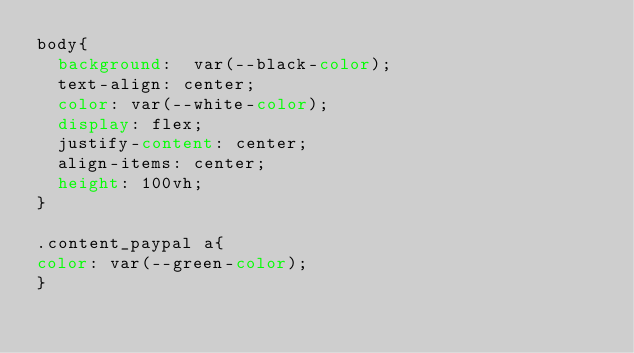Convert code to text. <code><loc_0><loc_0><loc_500><loc_500><_CSS_>body{
  background:  var(--black-color); 
  text-align: center;
  color: var(--white-color);
  display: flex;
  justify-content: center;
  align-items: center;
  height: 100vh;
}

.content_paypal a{
color: var(--green-color);
}</code> 